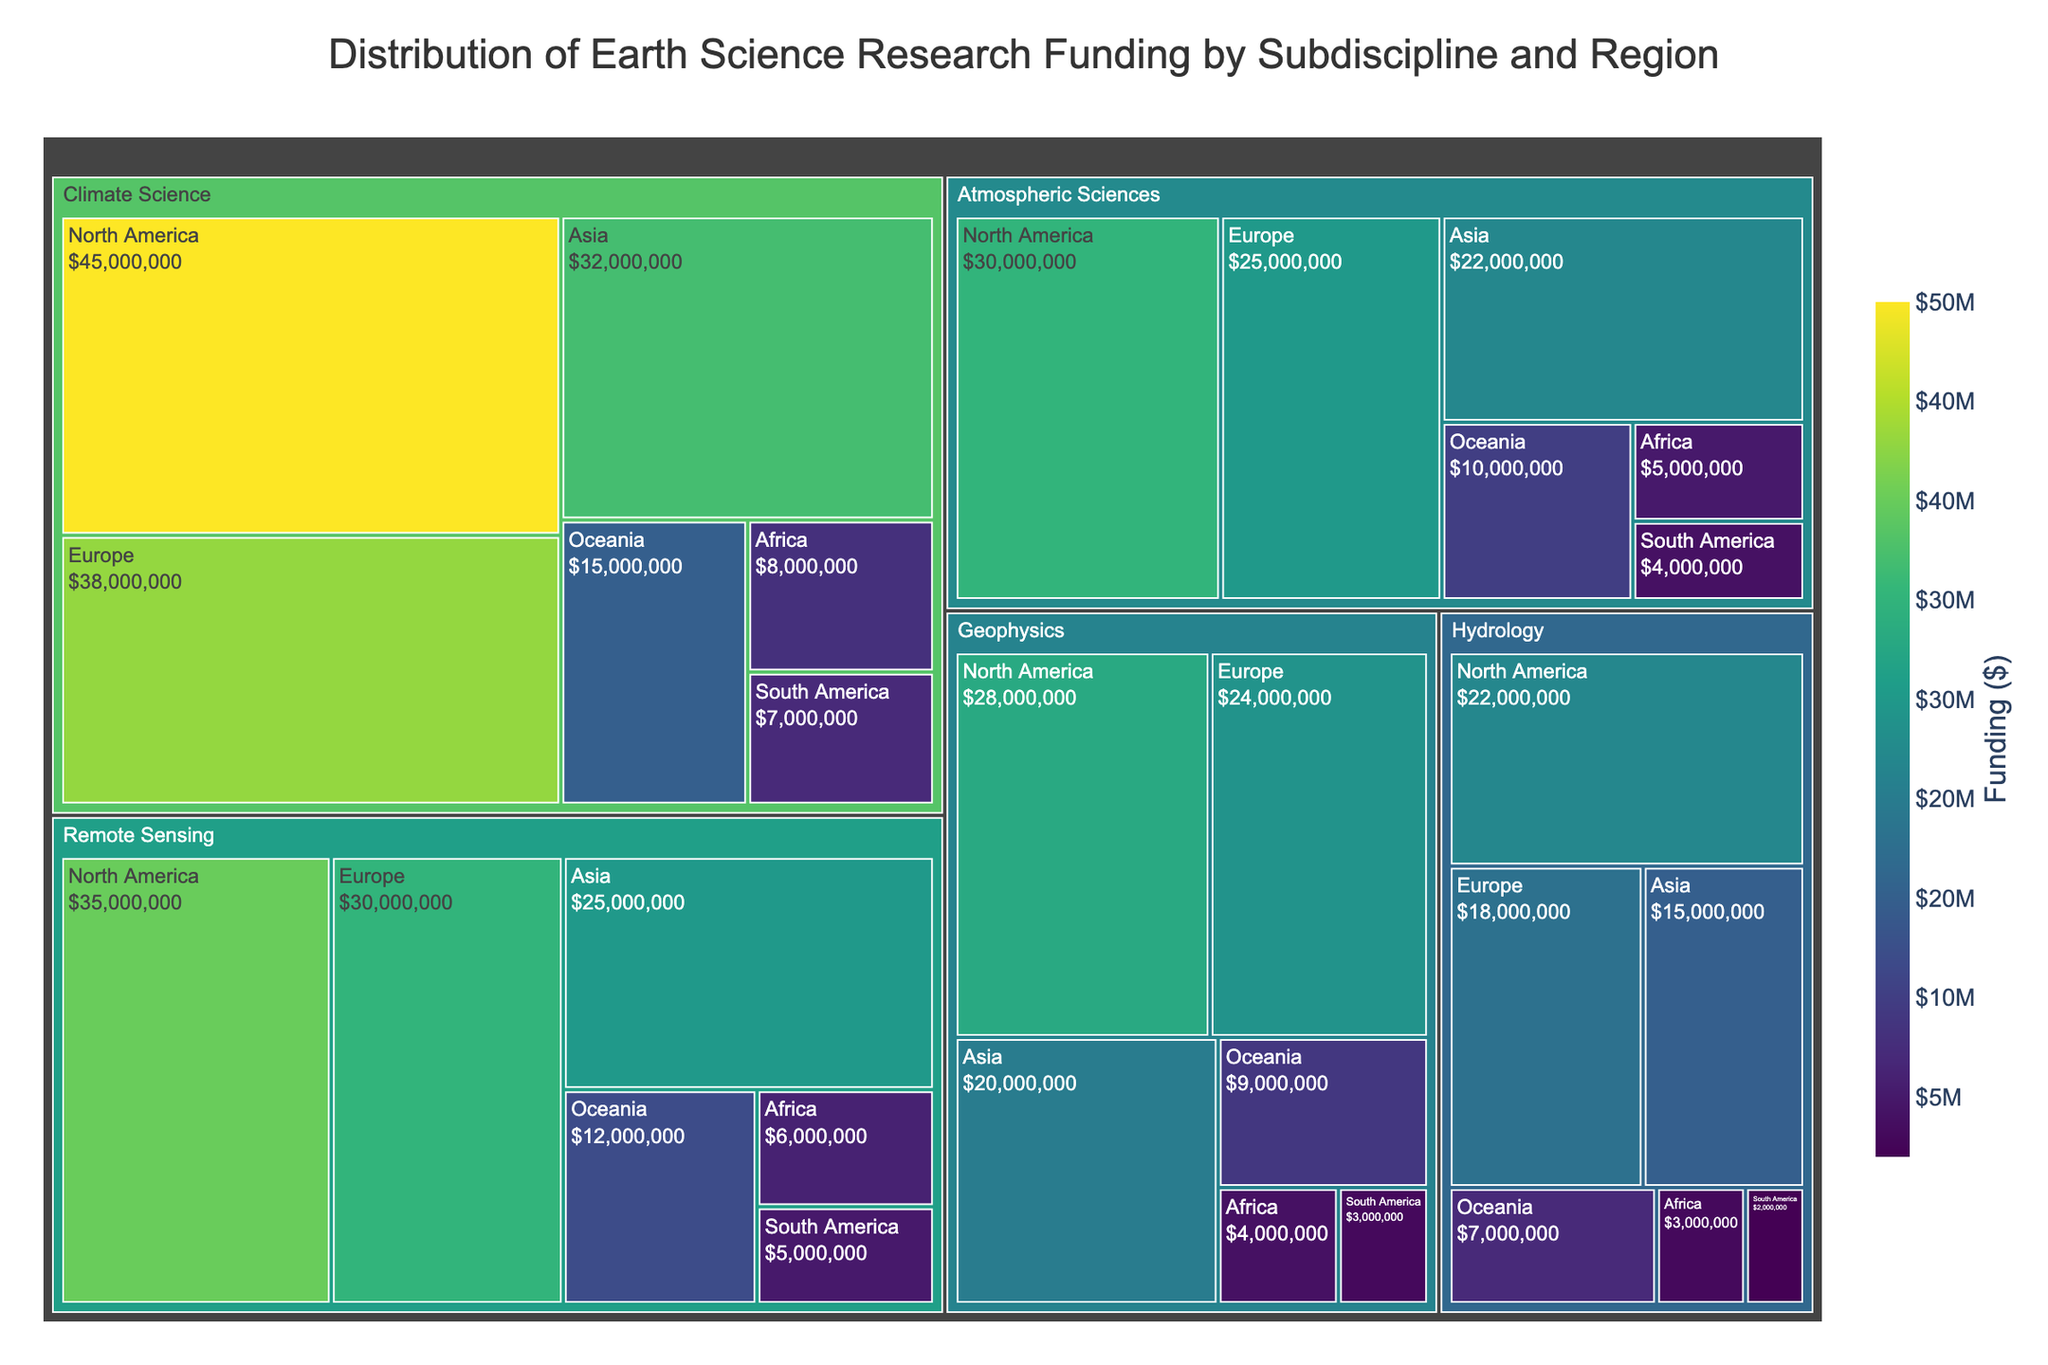What subdiscipline has the highest total funding? To determine this, sum the funding across all regions for each subdiscipline. Climate Science has $45M + $38M + $32M + $15M + $8M + $7M = $145M, which is the highest total funding.
Answer: Climate Science Which region receives the most funding for Remote Sensing? Look at the funding amounts for Remote Sensing across all regions: North America ($35M), Europe ($30M), Asia ($25M), Oceania ($12M), Africa ($6M), South America ($5M). North America has the highest funding.
Answer: North America What is the difference in funding between Geophysics in North America and Asia? The funding for Geophysics in North America is $28M and in Asia is $20M. The difference is $28M - $20M = $8M.
Answer: $8M Compare Climate Science funding in Europe and Asia. Which is higher and by how much? Climate Science funding in Europe is $38M and in Asia is $32M. Europe has higher funding by $38M - $32M = $6M.
Answer: Europe by $6M How much funding does Hydrology receive in Africa compared to South America? Compare the Hydrology funding in both regions: Africa ($3M) and South America ($2M). Africa has $3M - $2M = $1M more.
Answer: Africa by $1M What is the average funding for Atmospheric Sciences across all regions? Add the funding amounts for Atmospheric Sciences in all regions: $30M + $25M + $22M + $10M + $5M + $4M = $96M. There are 6 regions, so average funding is $96M / 6 = $16M.
Answer: $16M Which subdiscipline receives the least total funding in Oceania? Compare the Oceania funding amounts: Climate Science ($15M), Remote Sensing ($12M), Geophysics ($9M), Hydrology ($7M), Atmospheric Sciences ($10M). Hydrology has the least.
Answer: Hydrology Which region has the lowest total funding across all subdisciplines? Sum the funding for each region: North America ($45M + $35M + $28M + $22M + $30M = $160M), Europe ($38M + $30M + $24M + $18M + $25M = $135M), Asia ($32M + $25M + $20M + $15M + $22M = $114M), Oceania ($15M + $12M + $9M + $7M + $10M = $53M), Africa ($8M + $6M + $4M + $3M + $5M = $26M), South America ($7M + $5M + $3M + $2M + $4M = $21M). South America has the lowest.
Answer: South America What is the total funding for all Earth Science research in Asia? Sum the funding for all subdisciplines in Asia: $32M + $25M + $20M + $15M + $22M = $114M.
Answer: $114M What is the total number of regions shown in the treemap? Count the number of unique regions listed in the data: North America, Europe, Asia, Oceania, Africa, South America. There are 6 regions.
Answer: 6 